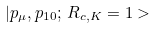<formula> <loc_0><loc_0><loc_500><loc_500>| p _ { \mu } , p _ { 1 0 } ; \, R _ { c , K } = { 1 > }</formula> 